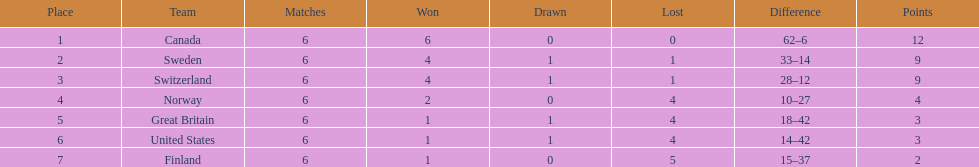Which nation excelled more in the 1951 world ice hockey championships, switzerland or great britain? Switzerland. 